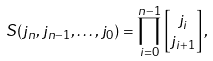Convert formula to latex. <formula><loc_0><loc_0><loc_500><loc_500>S ( j _ { n } , j _ { n - 1 } , \dots , j _ { 0 } ) & = \prod _ { i = 0 } ^ { n - 1 } \begin{bmatrix} j _ { i } \\ j _ { i + 1 } \\ \end{bmatrix} ,</formula> 